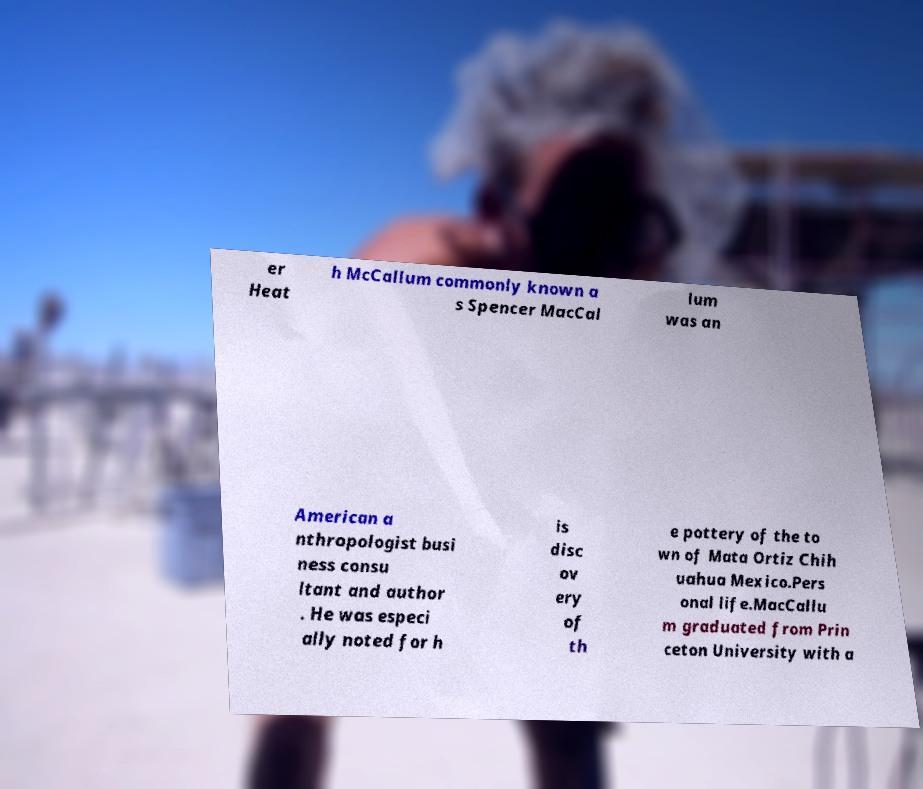Please read and relay the text visible in this image. What does it say? er Heat h McCallum commonly known a s Spencer MacCal lum was an American a nthropologist busi ness consu ltant and author . He was especi ally noted for h is disc ov ery of th e pottery of the to wn of Mata Ortiz Chih uahua Mexico.Pers onal life.MacCallu m graduated from Prin ceton University with a 